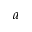Convert formula to latex. <formula><loc_0><loc_0><loc_500><loc_500>a</formula> 